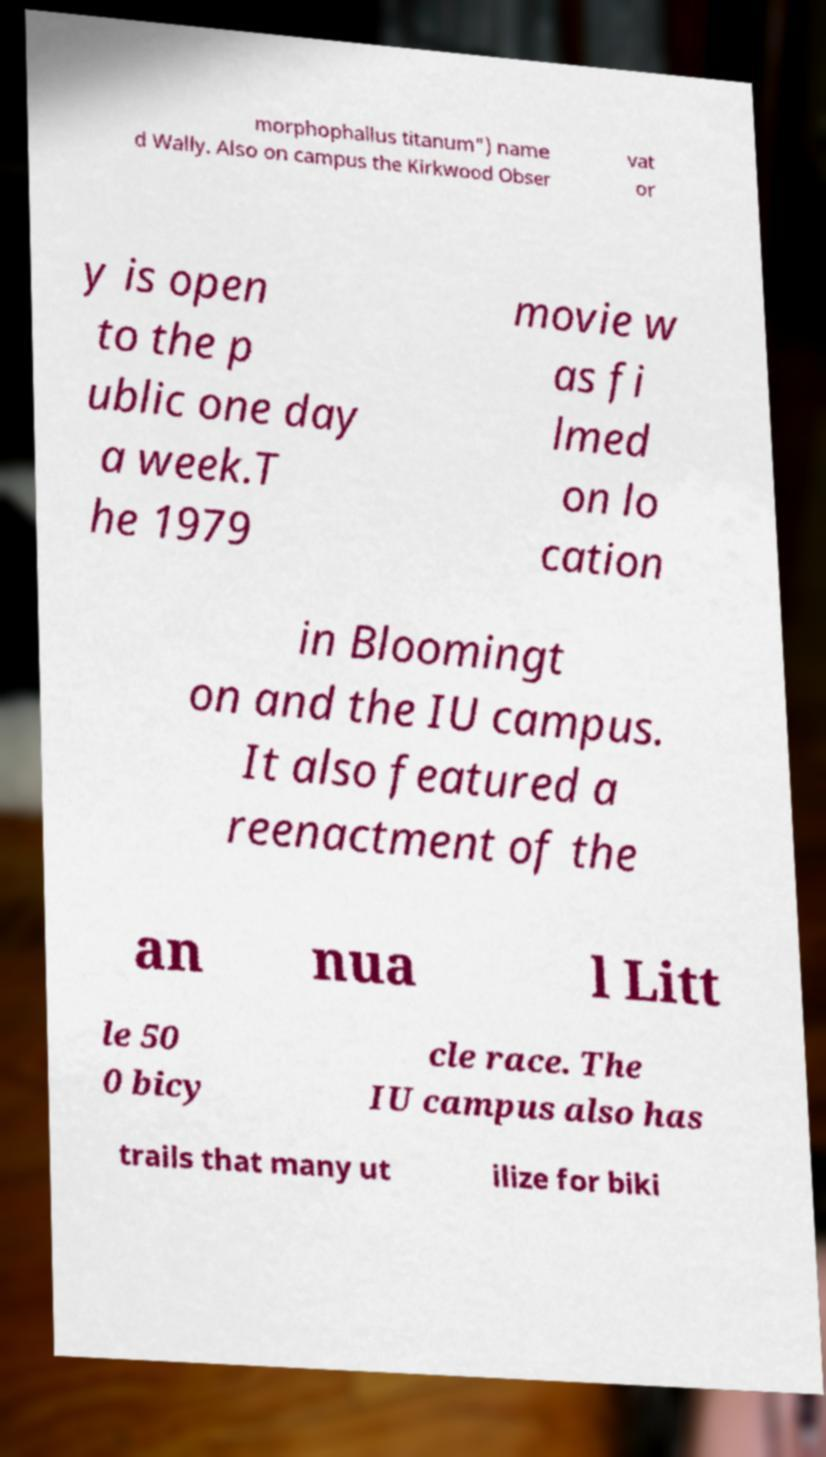Please identify and transcribe the text found in this image. morphophallus titanum") name d Wally. Also on campus the Kirkwood Obser vat or y is open to the p ublic one day a week.T he 1979 movie w as fi lmed on lo cation in Bloomingt on and the IU campus. It also featured a reenactment of the an nua l Litt le 50 0 bicy cle race. The IU campus also has trails that many ut ilize for biki 